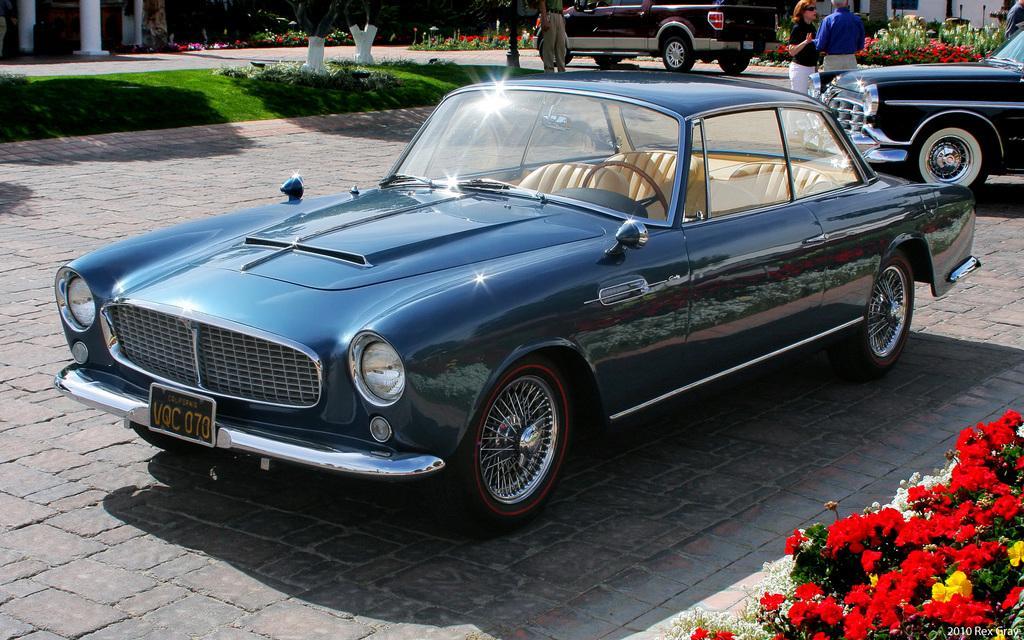Can you describe this image briefly? In this picture we can see vehicles, people on the ground, here we can see plants with flowers, grass, pillars, wall and some objects, in the bottom right of the image we can see some text on it. 